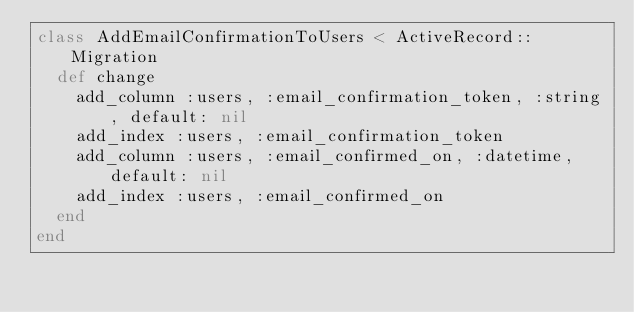Convert code to text. <code><loc_0><loc_0><loc_500><loc_500><_Ruby_>class AddEmailConfirmationToUsers < ActiveRecord::Migration
  def change
    add_column :users, :email_confirmation_token, :string, default: nil
    add_index :users, :email_confirmation_token
    add_column :users, :email_confirmed_on, :datetime, default: nil
    add_index :users, :email_confirmed_on
  end
end
</code> 